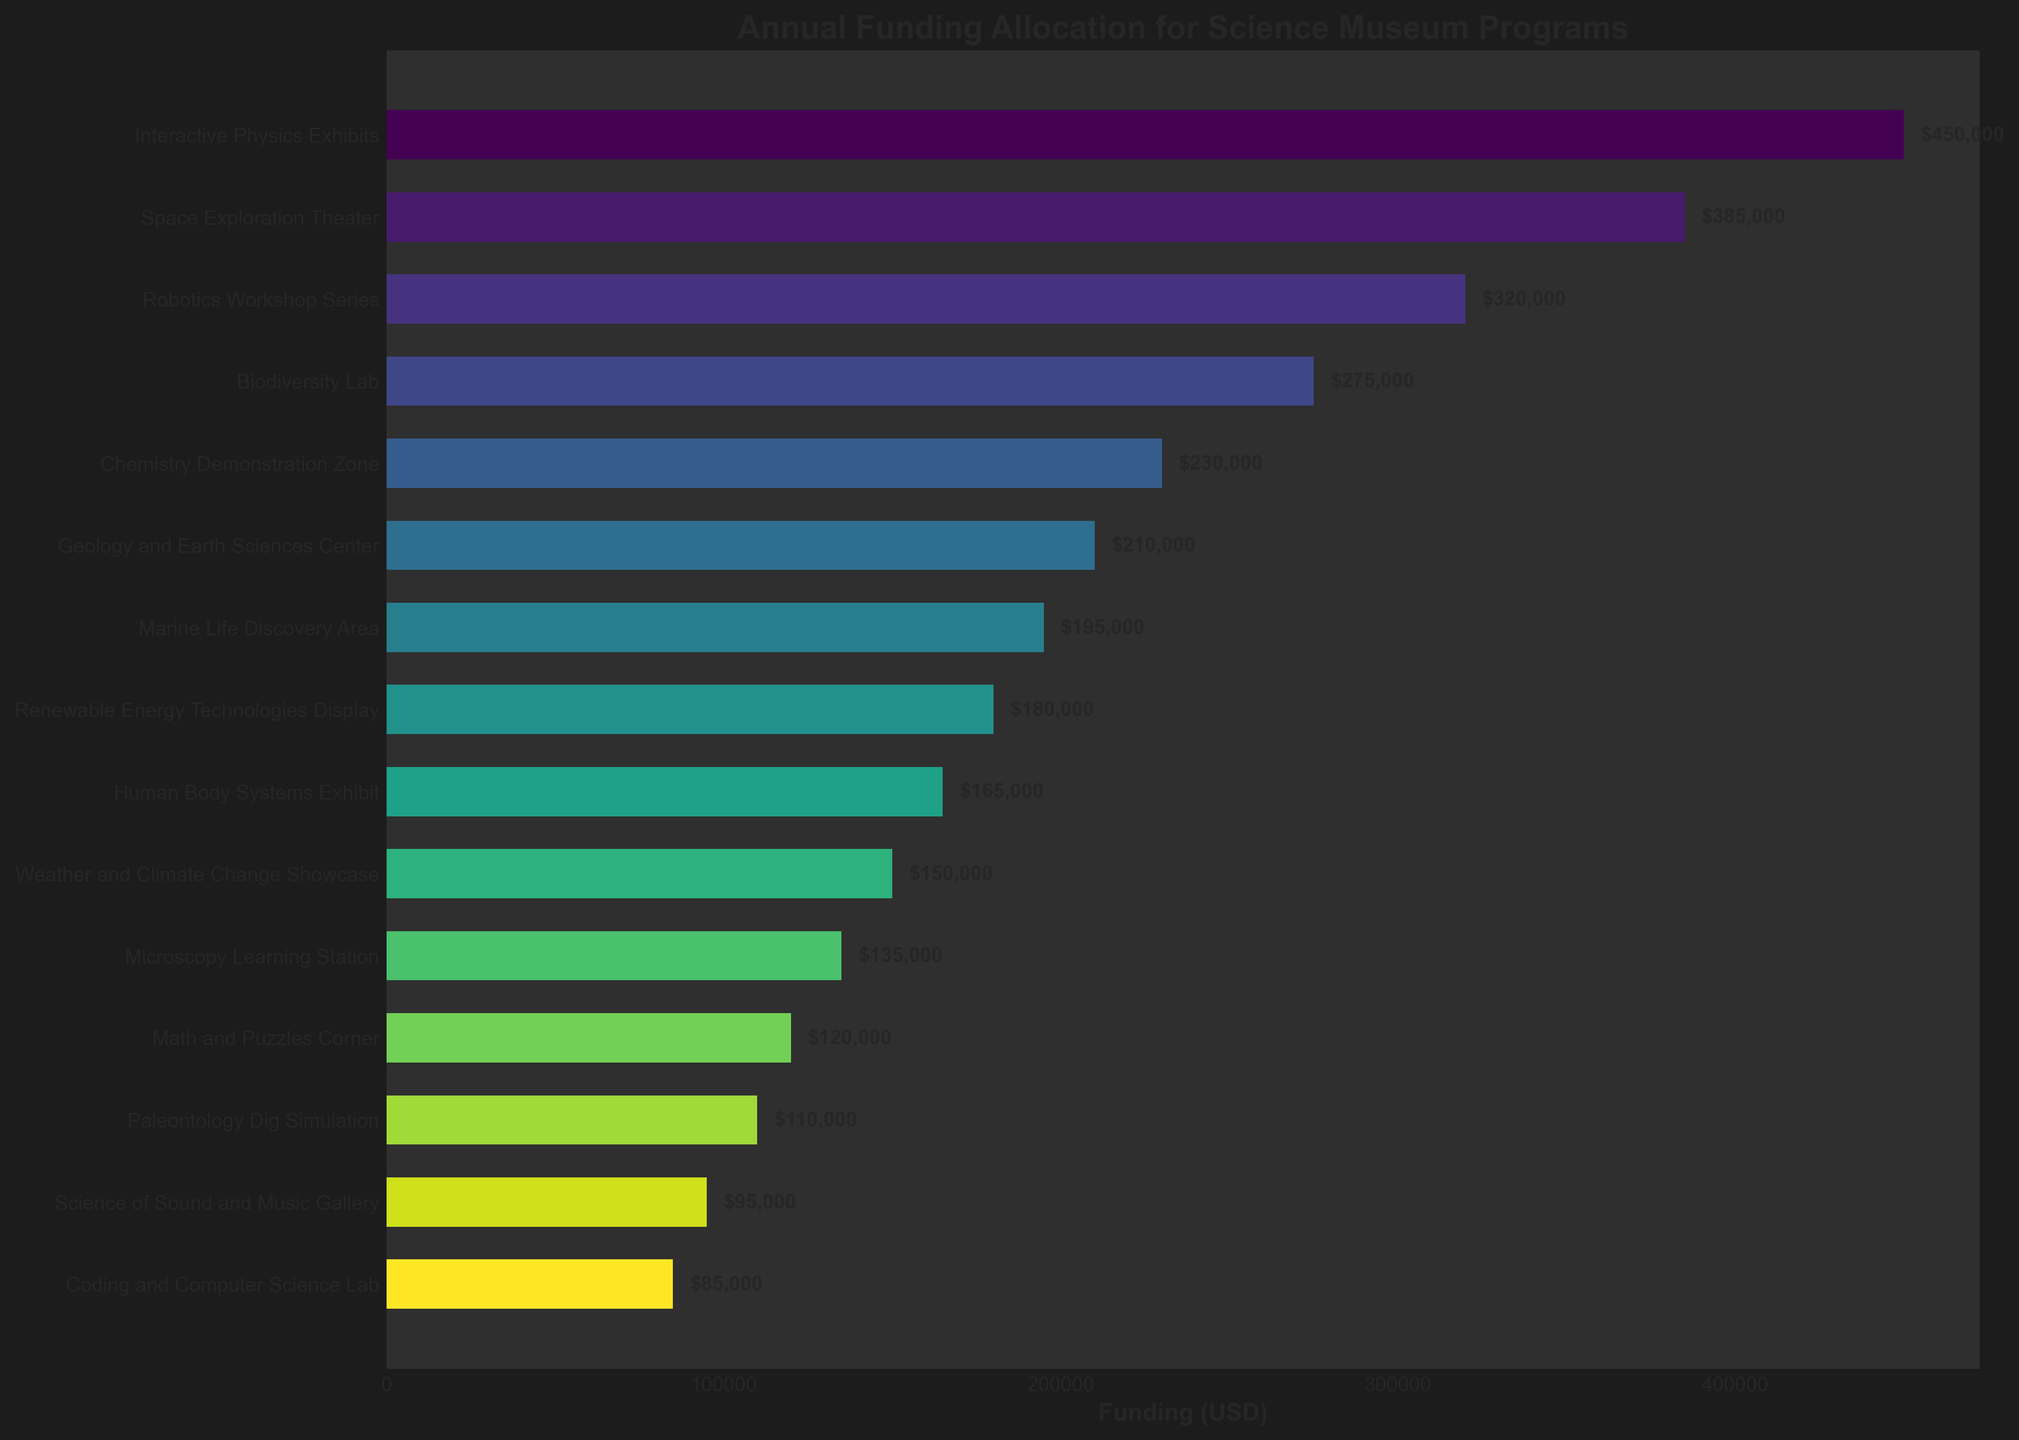Which program has received the highest funding? The bar representing Interactive Physics Exhibits reaches higher on the funding axis than any other bar.
Answer: Interactive Physics Exhibits Which program has received the lowest funding? The bar representing Coding and Computer Science Lab is the shortest, indicating the least funding.
Answer: Coding and Computer Science Lab What's the total funding for the top three funded programs combined? Interactive Physics Exhibits ($450,000), Space Exploration Theater ($385,000), and Robotics Workshop Series ($320,000) together amount to $450,000 + $385,000 + $320,000.
Answer: $1,155,000 How much more funding does the Interactive Physics Exhibits have compared to the Biodiversity Lab? Interactive Physics Exhibits received $450,000, and Biodiversity Lab received $275,000. The difference is $450,000 - $275,000.
Answer: $175,000 Which has more funding: the Geology and Earth Sciences Center or the Renewable Energy Technologies Display? The funding bar is higher for the Geology and Earth Sciences Center ($210,000) compared to the Renewable Energy Technologies Display ($180,000).
Answer: Geology and Earth Sciences Center What is the average funding for the top five funded programs? Sum the funding of the top five programs (Interactive Physics Exhibits: $450,000, Space Exploration Theater: $385,000, Robotics Workshop Series: $320,000, Biodiversity Lab: $275,000, Chemistry Demonstration Zone: $230,000) and divide by 5. ($450,000 + $385,000 + $320,000 + $275,000 + $230,000) / 5
Answer: $332,000 How many programs have received funding of less than $200,000? Count the bars that fall below the $200,000 line on the x-axis: Marine Life Discovery Area, Renewable Energy Technologies Display, Human Body Systems Exhibit, Weather and Climate Change Showcase, Microscopy Learning Station, Math and Puzzles Corner, Paleontology Dig Simulation, Science of Sound and Music Gallery, Coding and Computer Science Lab.
Answer: 9 What's the combined funding for the Weather and Climate Change Showcase and the Math and Puzzles Corner? Add the funding amounts for Weather and Climate Change Showcase ($150,000) and Math and Puzzles Corner ($120,000).
Answer: $270,000 What percentage of the total funding is allocated to the Interactive Physics Exhibits? The total funding is the sum of funding for all programs. Interactive Physics Exhibits received $450,000. To find the percentage: ($450,000 / Total Funding) * 100.
Answer: 15.42% (assuming total funding of $2,917,000) Which three programs are in the mid-range in terms of funding? Arrange all programs by their funding, then select the three in the middle (7th, 8th, 9th ranked): Human Body Systems Exhibit ($165,000), Weather and Climate Change Showcase ($150,000), Microscopy Learning Station ($135,000).
Answer: Human Body Systems Exhibit, Weather and Climate Change Showcase, Microscopy Learning Station 